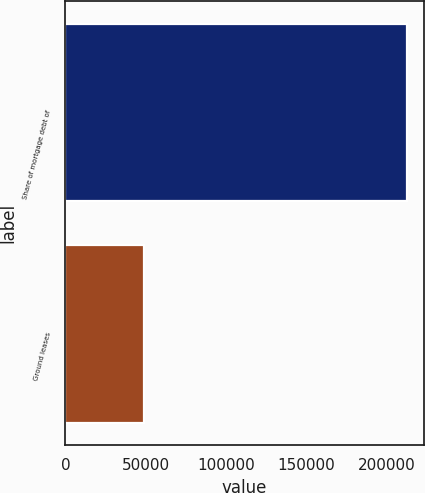Convert chart. <chart><loc_0><loc_0><loc_500><loc_500><bar_chart><fcel>Share of mortgage debt of<fcel>Ground leases<nl><fcel>212210<fcel>48655<nl></chart> 